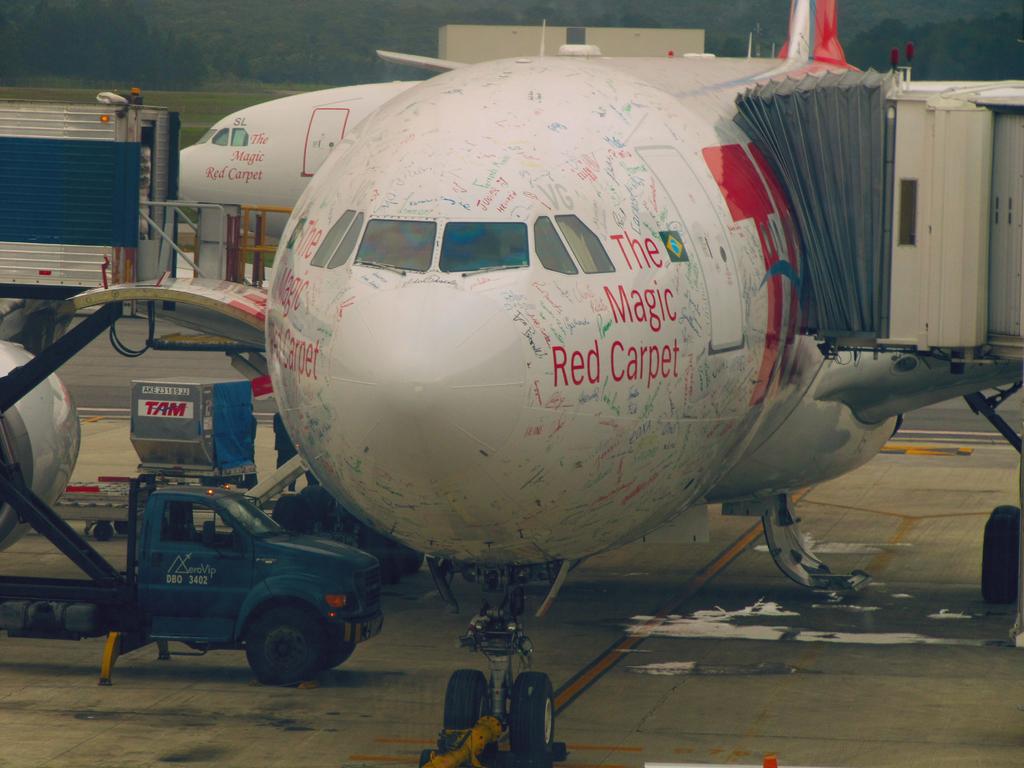What is the name of the plane?
Your answer should be compact. The magic red carpet. 